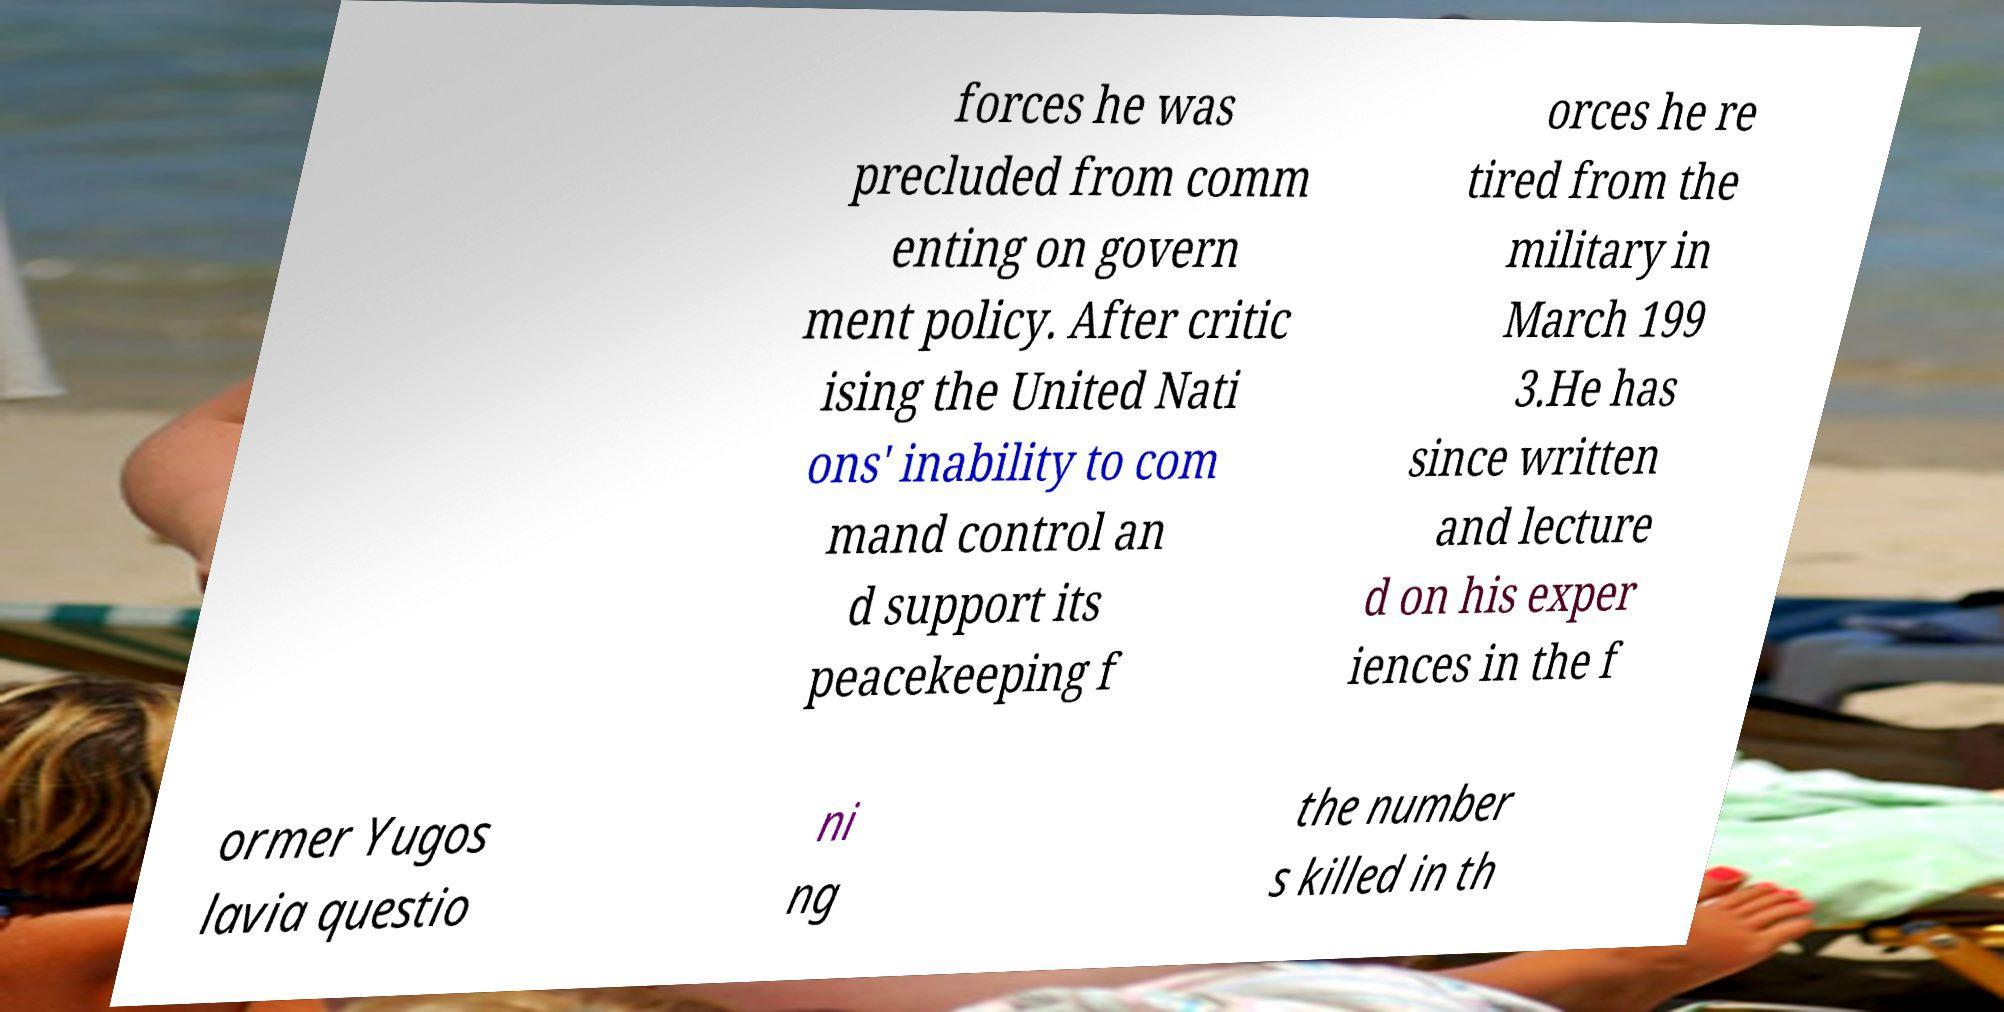Could you extract and type out the text from this image? forces he was precluded from comm enting on govern ment policy. After critic ising the United Nati ons' inability to com mand control an d support its peacekeeping f orces he re tired from the military in March 199 3.He has since written and lecture d on his exper iences in the f ormer Yugos lavia questio ni ng the number s killed in th 